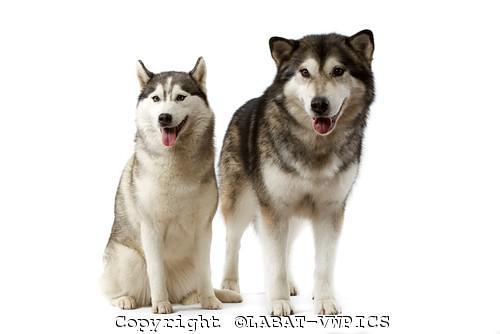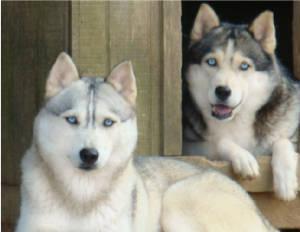The first image is the image on the left, the second image is the image on the right. Considering the images on both sides, is "The left image features two huskies side by side, with at least one sitting upright, and the right image contains two dogs, with at least one reclining." valid? Answer yes or no. Yes. 